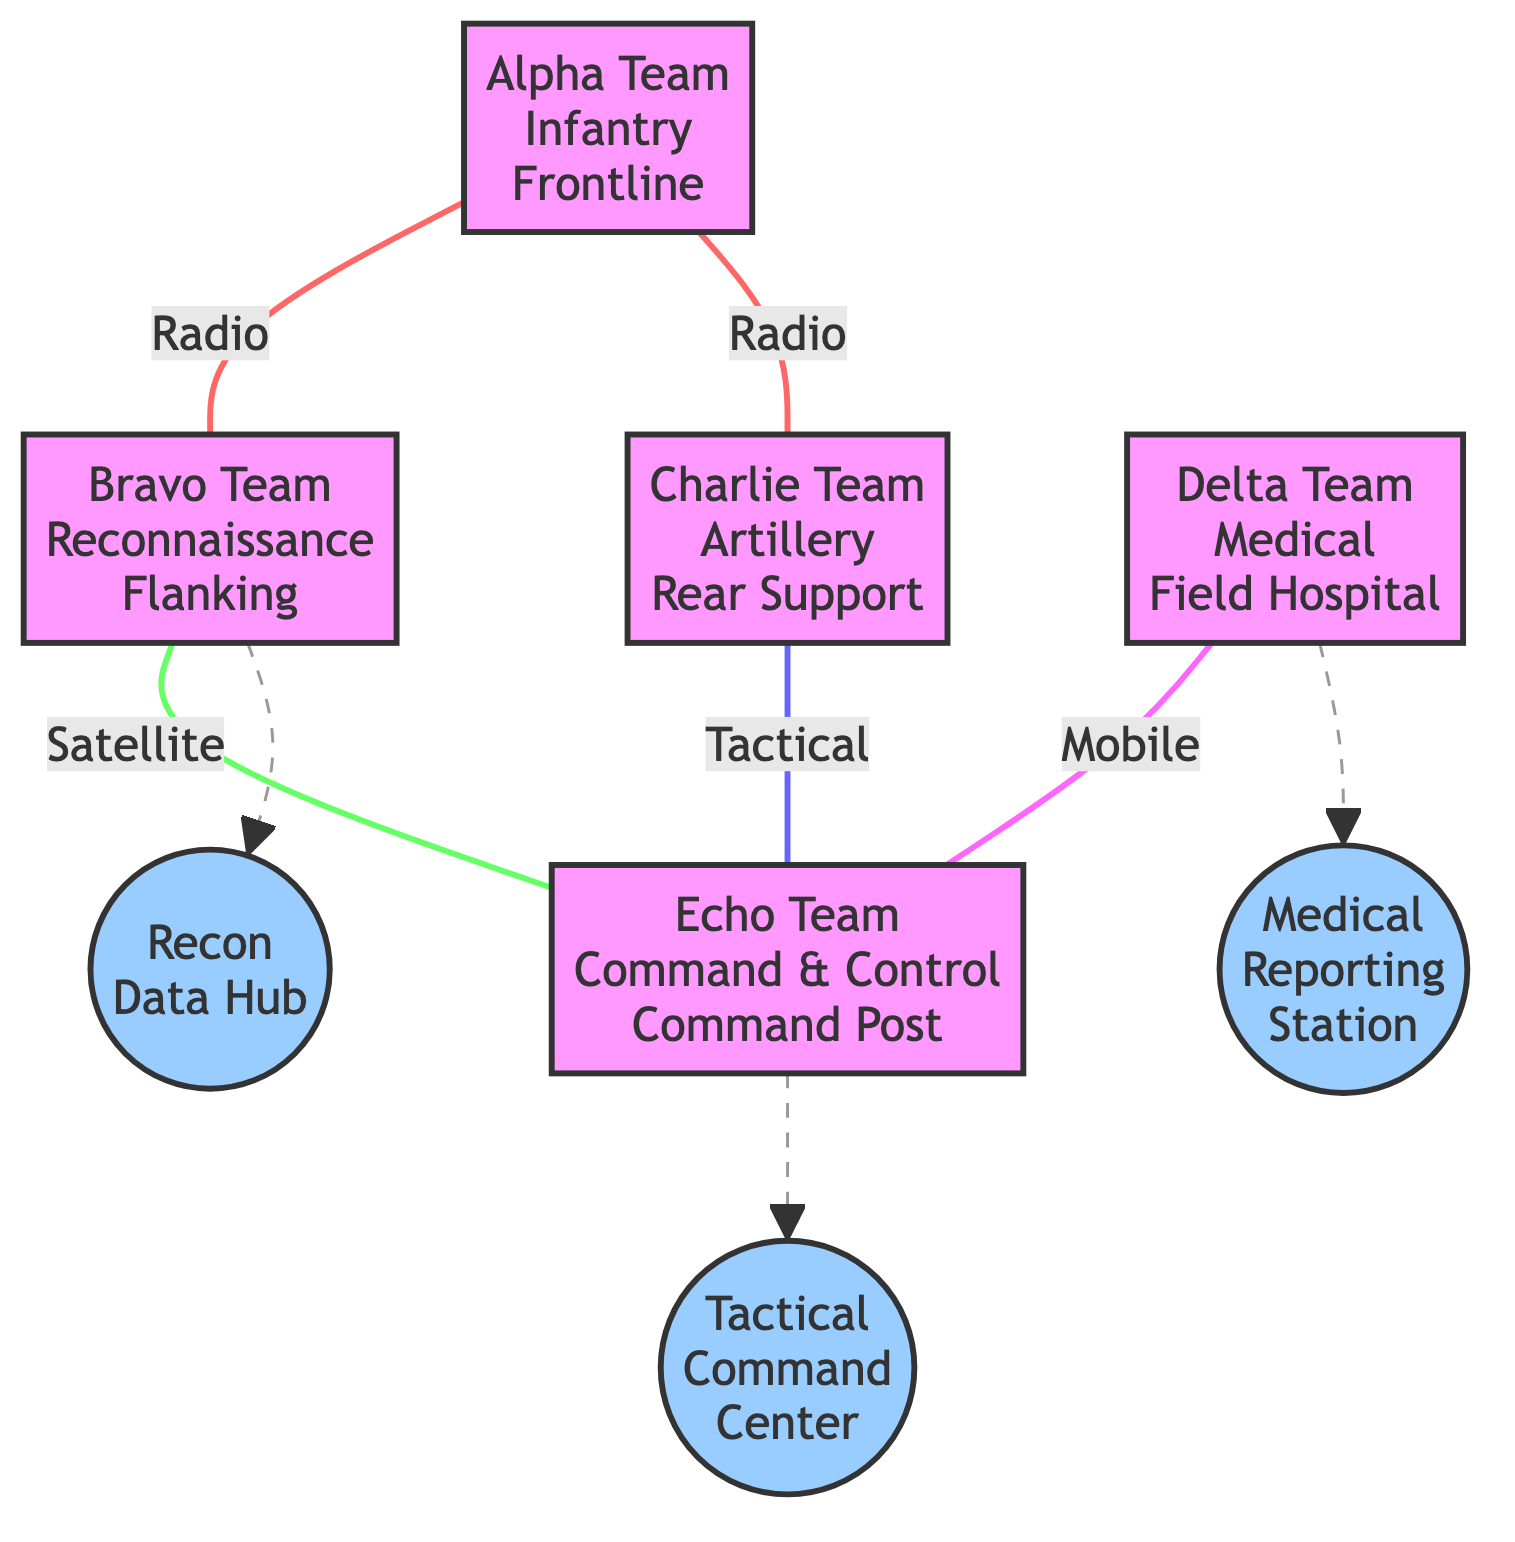What's the role of Bravo Team? The role of Bravo Team is specified in the diagram. It shows that Bravo Team is responsible for reconnaissance.
Answer: Reconnaissance How many units are shown in the diagram? To answer this, count the number of distinct units represented in the diagram. There are five units: Alpha Team, Bravo Team, Charlie Team, Delta Team, and Echo Team.
Answer: Five Which communication device does Delta Team use? The communication device used by Delta Team is highlighted in the diagram. It states that Delta Team uses a mobile network for communication.
Answer: Mobile Network What type of data is associated with the Recon Data Hub? The diagram indicates that the Recon Data Hub is specifically associated with Bravo Team and handles real-time reconnaissance data.
Answer: Real-time reconnaissance Which team has a direct communication line with Echo Team? To determine this, look for lines that connect other teams directly to Echo Team. Bravo Team, Charlie Team, and Delta Team all have direct lines to Echo Team.
Answer: Three teams What is the communication type between Alpha Team and Bravo Team? The type of communication line between Alpha Team and Bravo Team is indicated directly in the diagram. It shows that they communicate via radio.
Answer: Radio What is the frequency of data transmitted at the Tactical Command Center? The diagram specifies that the Tactical Command Center associated with Echo Team transmits strategic decisions in real-time.
Answer: Real-time What position does Charlie Team occupy during the exercise? The position of Charlie Team is mentioned in the diagram, which states that Charlie Team is located in the rear support position.
Answer: Rear Support Which units share data with Echo Team? To find this, identify which units are linked to Echo Team for data sharing. The units that share data with Echo Team are Bravo Team and Charlie Team as well as Delta Team.
Answer: Three units What type of communication line is used by Charlie Team to communicate with Echo Team? The diagram clearly states the type of communication line from Charlie Team to Echo Team is tactical.
Answer: Tactical 